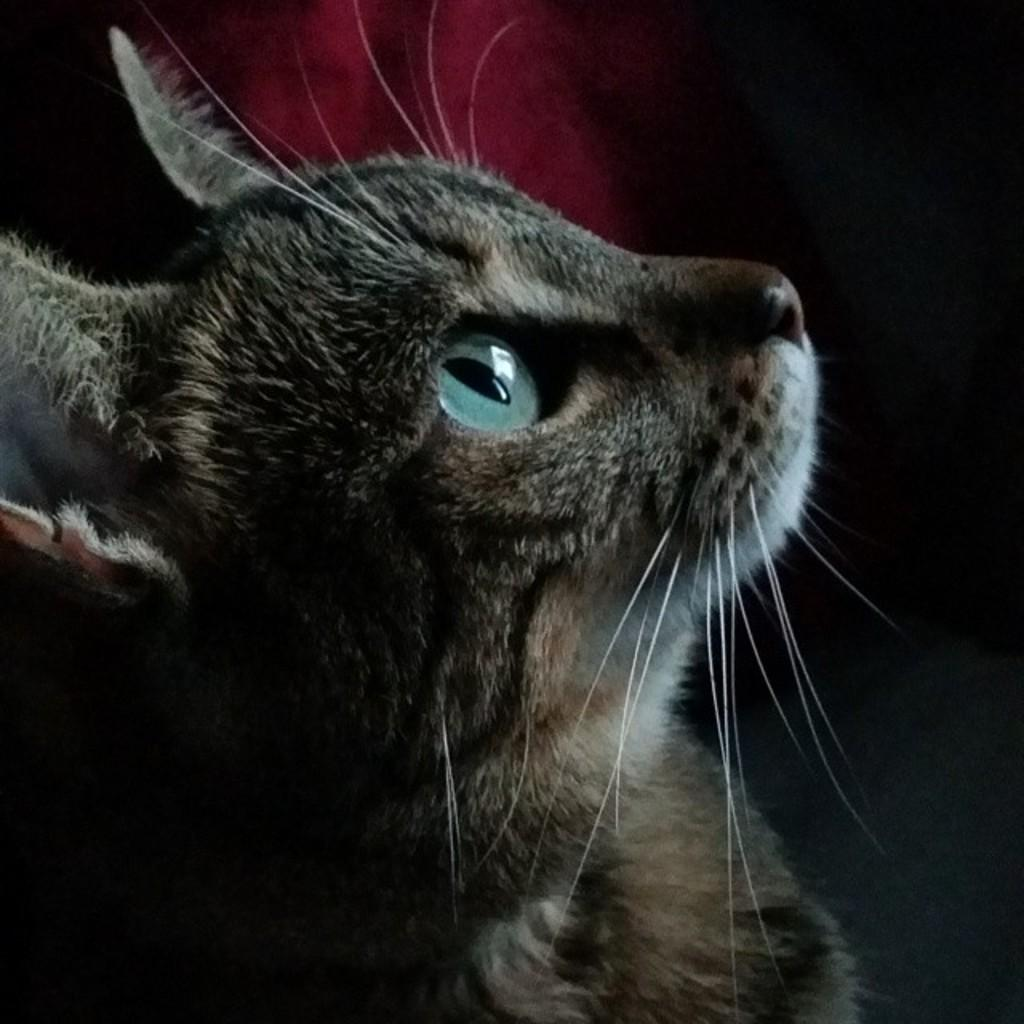What type of animal is in the image? There is a cat in the image. What color is the cat? The cat is brown in color. What verse is the actor reciting in the image? There is no actor or verse present in the image; it features a brown cat. Who is the recipient of the parcel in the image? There is no parcel or recipient present in the image; it features a brown cat. 